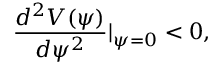Convert formula to latex. <formula><loc_0><loc_0><loc_500><loc_500>\frac { d ^ { 2 } V ( \psi ) } { d \psi ^ { 2 } } | _ { \psi = 0 } < 0 ,</formula> 